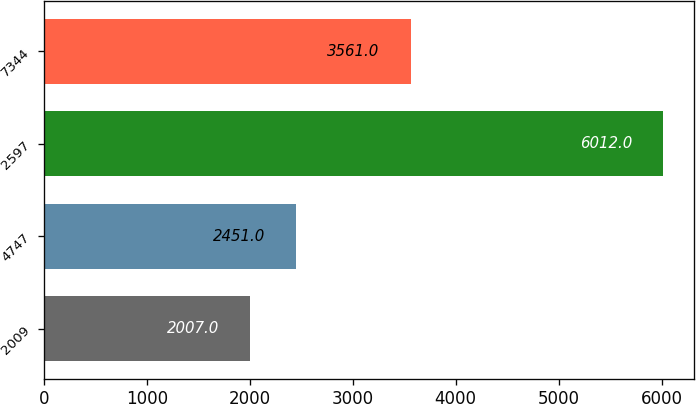Convert chart. <chart><loc_0><loc_0><loc_500><loc_500><bar_chart><fcel>2009<fcel>4747<fcel>2597<fcel>7344<nl><fcel>2007<fcel>2451<fcel>6012<fcel>3561<nl></chart> 